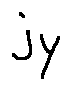Convert formula to latex. <formula><loc_0><loc_0><loc_500><loc_500>j _ { y }</formula> 